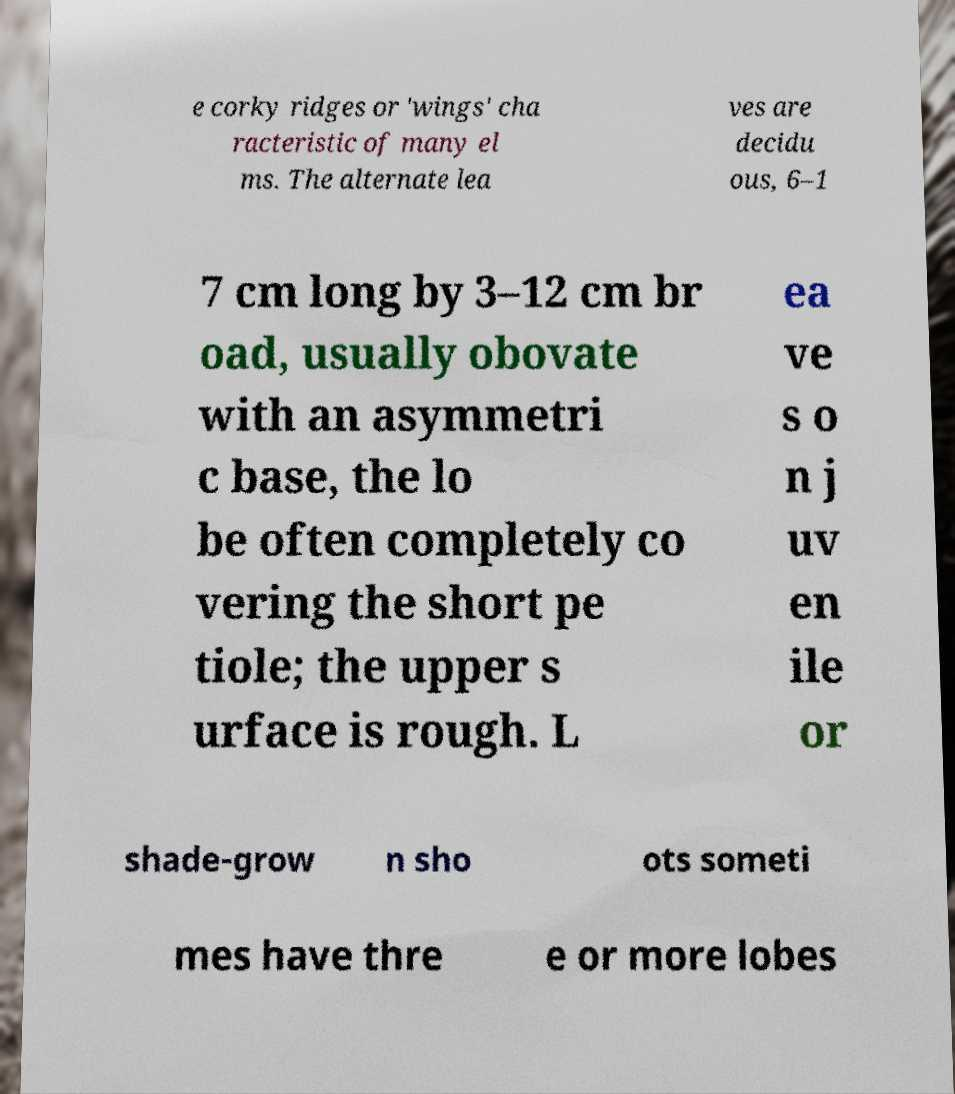Please identify and transcribe the text found in this image. e corky ridges or 'wings' cha racteristic of many el ms. The alternate lea ves are decidu ous, 6–1 7 cm long by 3–12 cm br oad, usually obovate with an asymmetri c base, the lo be often completely co vering the short pe tiole; the upper s urface is rough. L ea ve s o n j uv en ile or shade-grow n sho ots someti mes have thre e or more lobes 